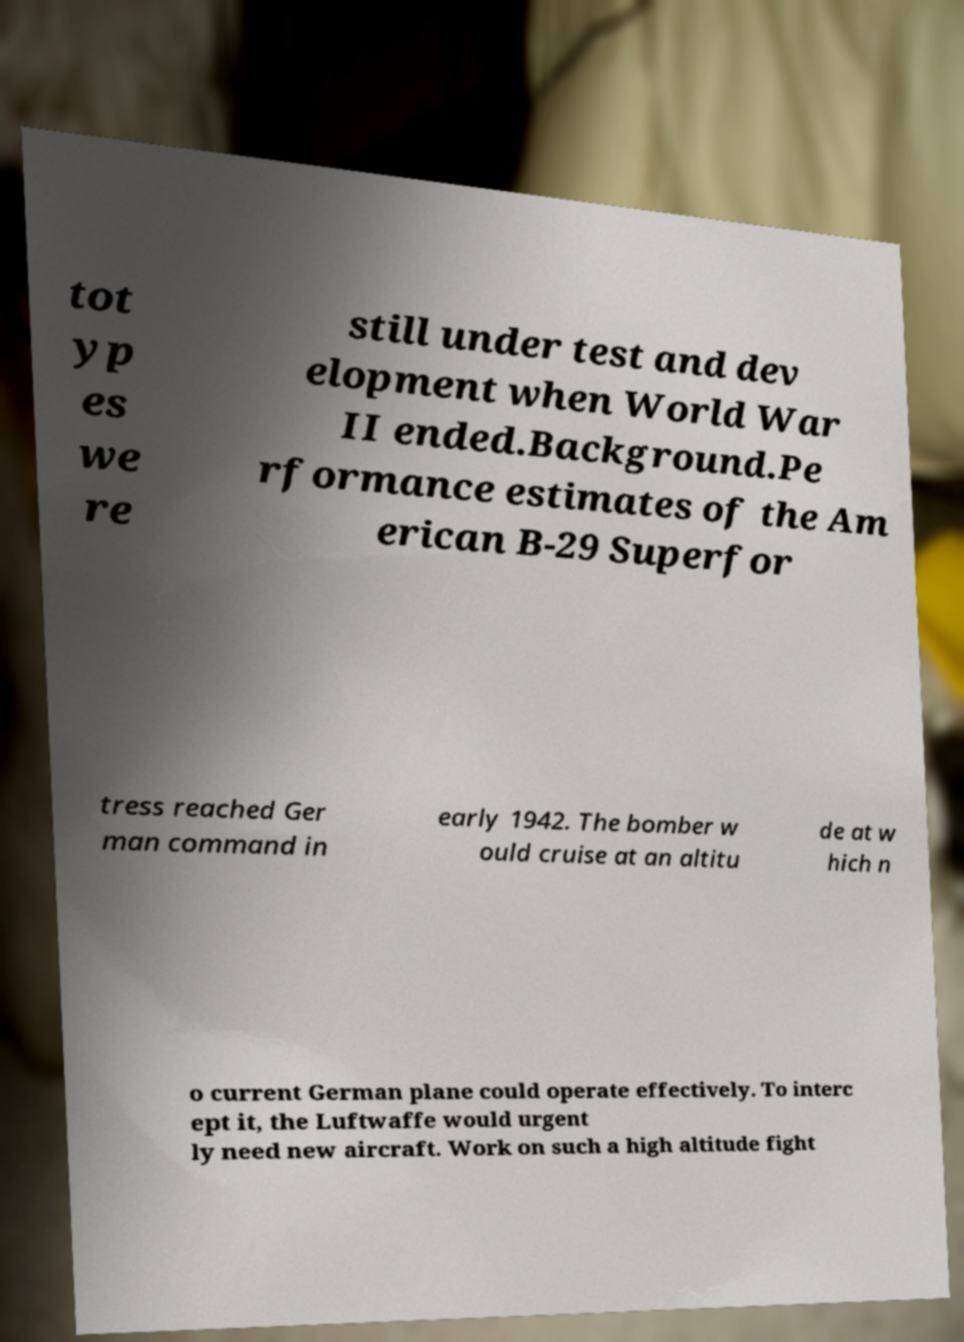Could you extract and type out the text from this image? tot yp es we re still under test and dev elopment when World War II ended.Background.Pe rformance estimates of the Am erican B-29 Superfor tress reached Ger man command in early 1942. The bomber w ould cruise at an altitu de at w hich n o current German plane could operate effectively. To interc ept it, the Luftwaffe would urgent ly need new aircraft. Work on such a high altitude fight 